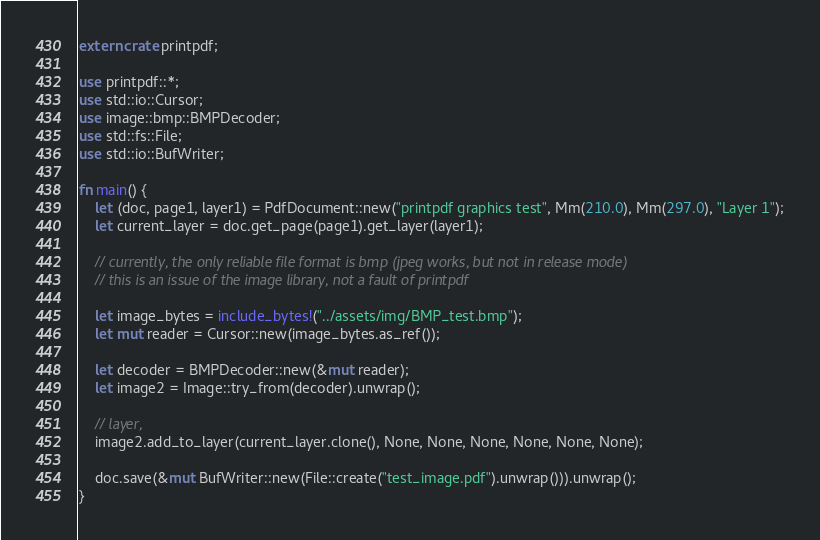<code> <loc_0><loc_0><loc_500><loc_500><_Rust_>extern crate printpdf;

use printpdf::*;
use std::io::Cursor;
use image::bmp::BMPDecoder;
use std::fs::File;
use std::io::BufWriter;

fn main() {
    let (doc, page1, layer1) = PdfDocument::new("printpdf graphics test", Mm(210.0), Mm(297.0), "Layer 1");
    let current_layer = doc.get_page(page1).get_layer(layer1);

    // currently, the only reliable file format is bmp (jpeg works, but not in release mode)
    // this is an issue of the image library, not a fault of printpdf

    let image_bytes = include_bytes!("../assets/img/BMP_test.bmp");
    let mut reader = Cursor::new(image_bytes.as_ref());

    let decoder = BMPDecoder::new(&mut reader);
    let image2 = Image::try_from(decoder).unwrap();

    // layer,     
    image2.add_to_layer(current_layer.clone(), None, None, None, None, None, None);

    doc.save(&mut BufWriter::new(File::create("test_image.pdf").unwrap())).unwrap();
}</code> 